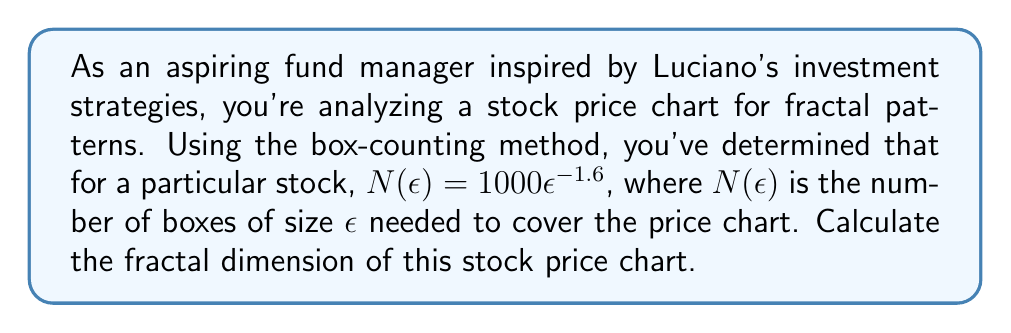Help me with this question. To calculate the fractal dimension using the box-counting method, we follow these steps:

1. Recall the box-counting dimension formula:
   $$D = \lim_{\epsilon \to 0} \frac{\log N(\epsilon)}{\log(1/\epsilon)}$$

2. We're given that $N(\epsilon) = 1000\epsilon^{-1.6}$. Let's substitute this into our formula:
   $$D = \lim_{\epsilon \to 0} \frac{\log(1000\epsilon^{-1.6})}{\log(1/\epsilon)}$$

3. Using the properties of logarithms, we can simplify the numerator:
   $$D = \lim_{\epsilon \to 0} \frac{\log(1000) + \log(\epsilon^{-1.6})}{\log(1/\epsilon)}$$
   $$D = \lim_{\epsilon \to 0} \frac{\log(1000) - 1.6\log(\epsilon)}{\log(1/\epsilon)}$$

4. As $\epsilon \to 0$, $\log(1000)$ becomes negligible compared to $\log(\epsilon)$, so we can simplify:
   $$D = \lim_{\epsilon \to 0} \frac{-1.6\log(\epsilon)}{\log(1/\epsilon)}$$

5. Note that $\log(1/\epsilon) = -\log(\epsilon)$, so we have:
   $$D = \lim_{\epsilon \to 0} \frac{-1.6\log(\epsilon)}{-\log(\epsilon)} = 1.6$$

Therefore, the fractal dimension of the stock price chart is 1.6.
Answer: 1.6 